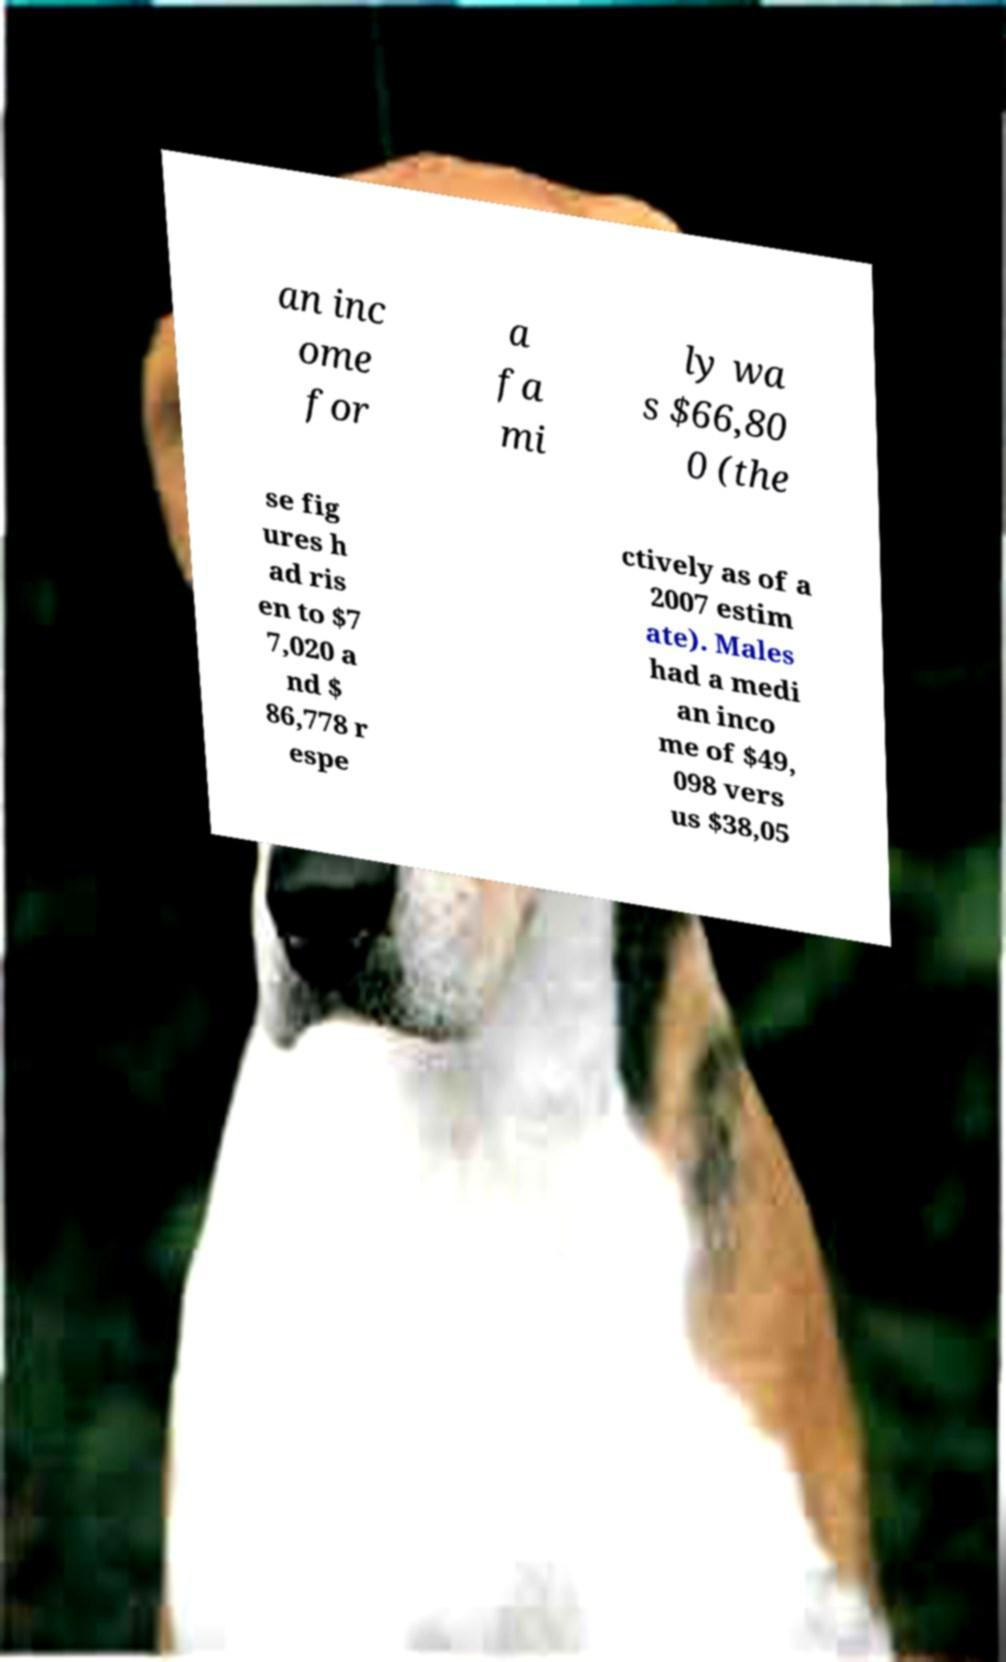Please identify and transcribe the text found in this image. an inc ome for a fa mi ly wa s $66,80 0 (the se fig ures h ad ris en to $7 7,020 a nd $ 86,778 r espe ctively as of a 2007 estim ate). Males had a medi an inco me of $49, 098 vers us $38,05 